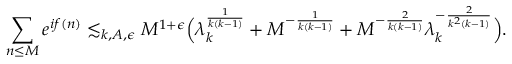Convert formula to latex. <formula><loc_0><loc_0><loc_500><loc_500>\sum _ { n \leq M } e ^ { i f ( n ) } \lesssim _ { k , A , \epsilon } M ^ { 1 + \epsilon } \left ( \lambda _ { k } ^ { \frac { 1 } { k ( k - 1 ) } } + M ^ { - \frac { 1 } { k ( k - 1 ) } } + M ^ { - \frac { 2 } { k ( k - 1 ) } } \lambda _ { k } ^ { - \frac { 2 } { k ^ { 2 } ( k - 1 ) } } \right ) .</formula> 